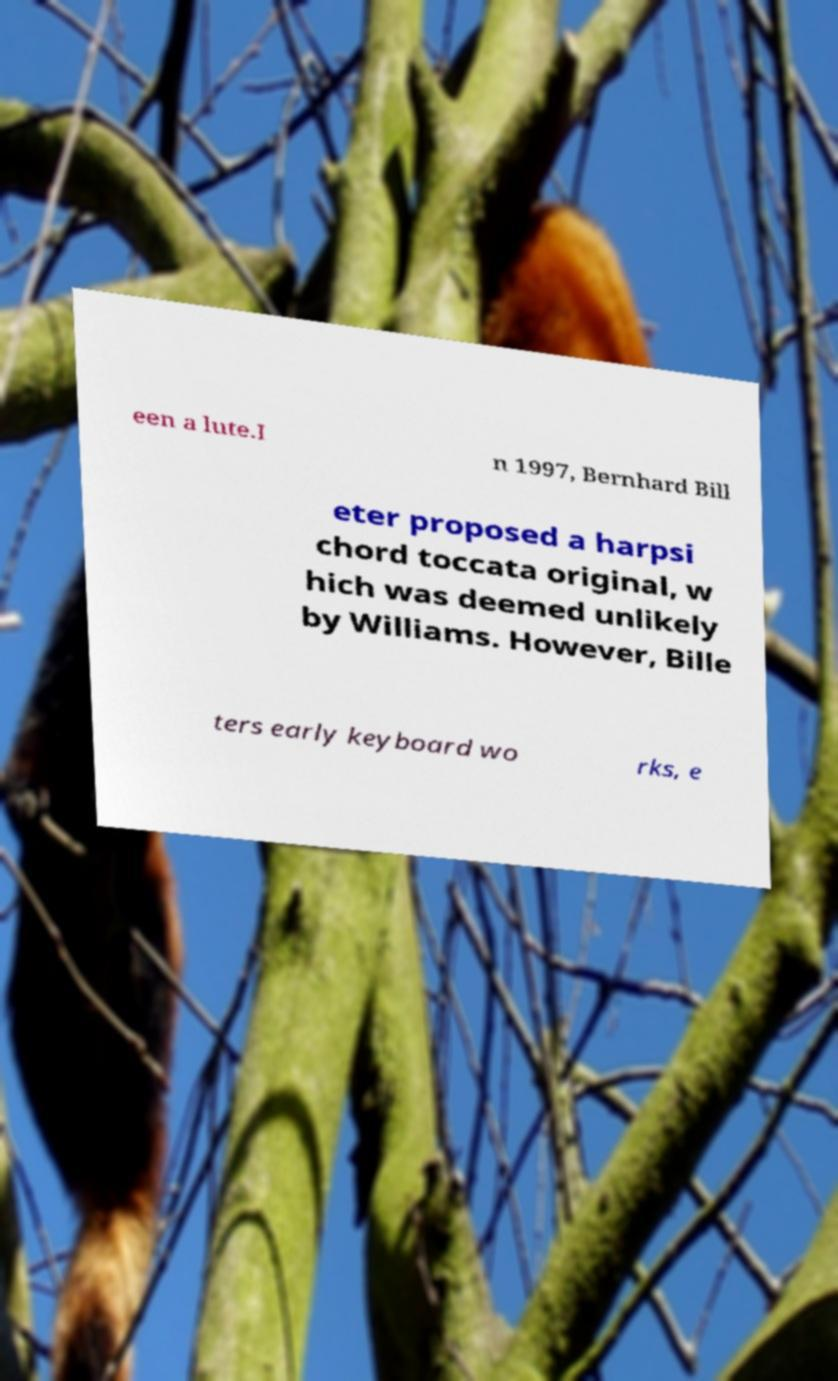Please read and relay the text visible in this image. What does it say? een a lute.I n 1997, Bernhard Bill eter proposed a harpsi chord toccata original, w hich was deemed unlikely by Williams. However, Bille ters early keyboard wo rks, e 